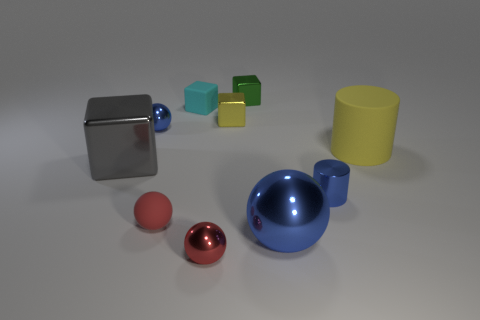What material is the cyan object that is the same size as the red metal sphere?
Make the answer very short. Rubber. How many small objects are either cylinders or yellow matte cylinders?
Ensure brevity in your answer.  1. What number of objects are either blue balls that are right of the tiny green shiny object or big metal things on the right side of the cyan block?
Your response must be concise. 1. Is the number of large gray shiny cubes less than the number of small metallic blocks?
Provide a short and direct response. Yes. There is a blue thing that is the same size as the yellow matte object; what is its shape?
Ensure brevity in your answer.  Sphere. How many other things are the same color as the large cylinder?
Your response must be concise. 1. What number of metallic cylinders are there?
Give a very brief answer. 1. How many blue things are both to the left of the small yellow block and in front of the big yellow cylinder?
Provide a short and direct response. 0. What material is the small blue cylinder?
Provide a succinct answer. Metal. Are any big brown rubber cylinders visible?
Your answer should be very brief. No. 